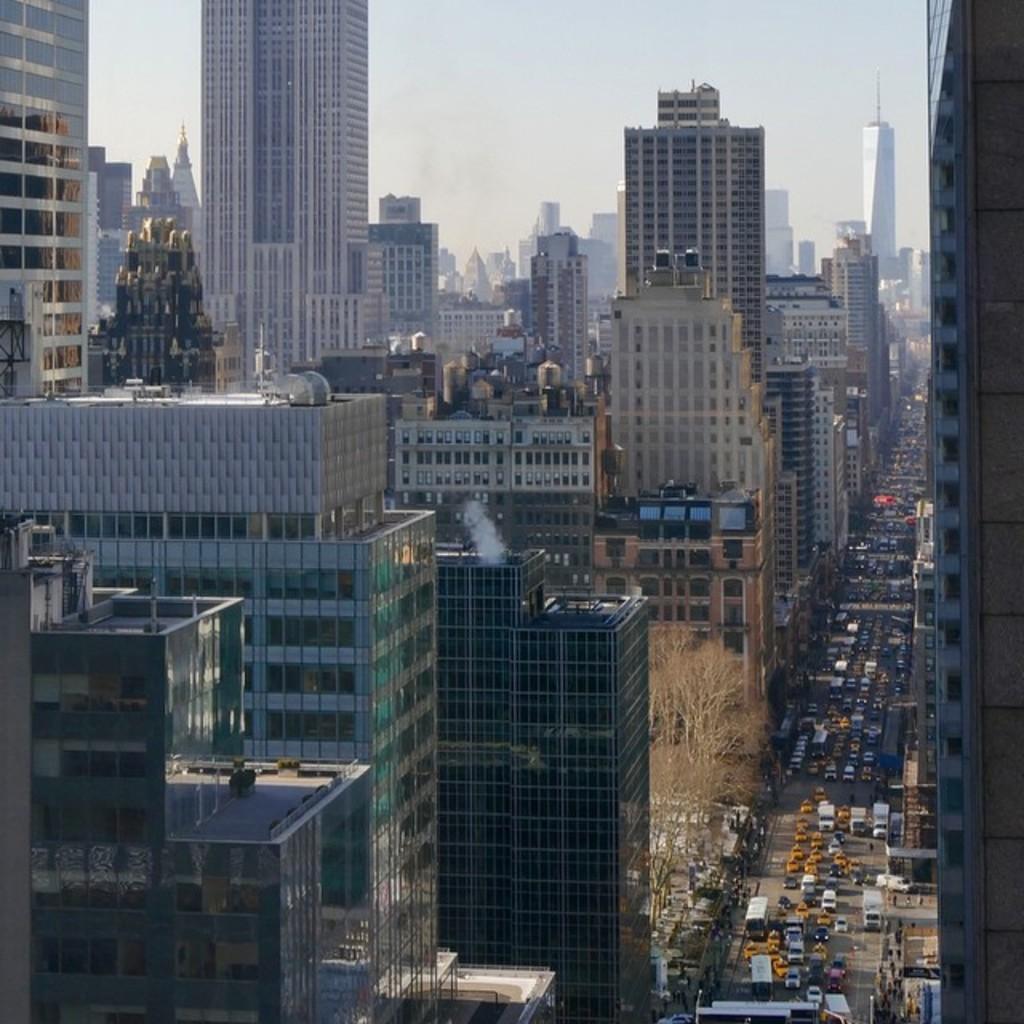Could you give a brief overview of what you see in this image? In this image I can see few vehicles. In the background I can see few buildings in white and brown color and the sky is in white color. 